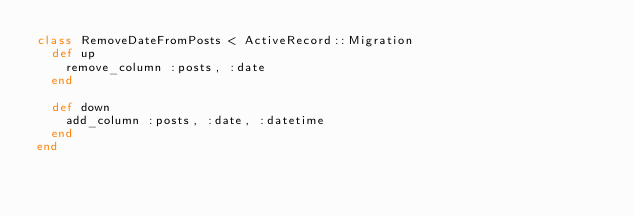Convert code to text. <code><loc_0><loc_0><loc_500><loc_500><_Ruby_>class RemoveDateFromPosts < ActiveRecord::Migration
  def up
    remove_column :posts, :date
  end

  def down
    add_column :posts, :date, :datetime
  end
end
</code> 